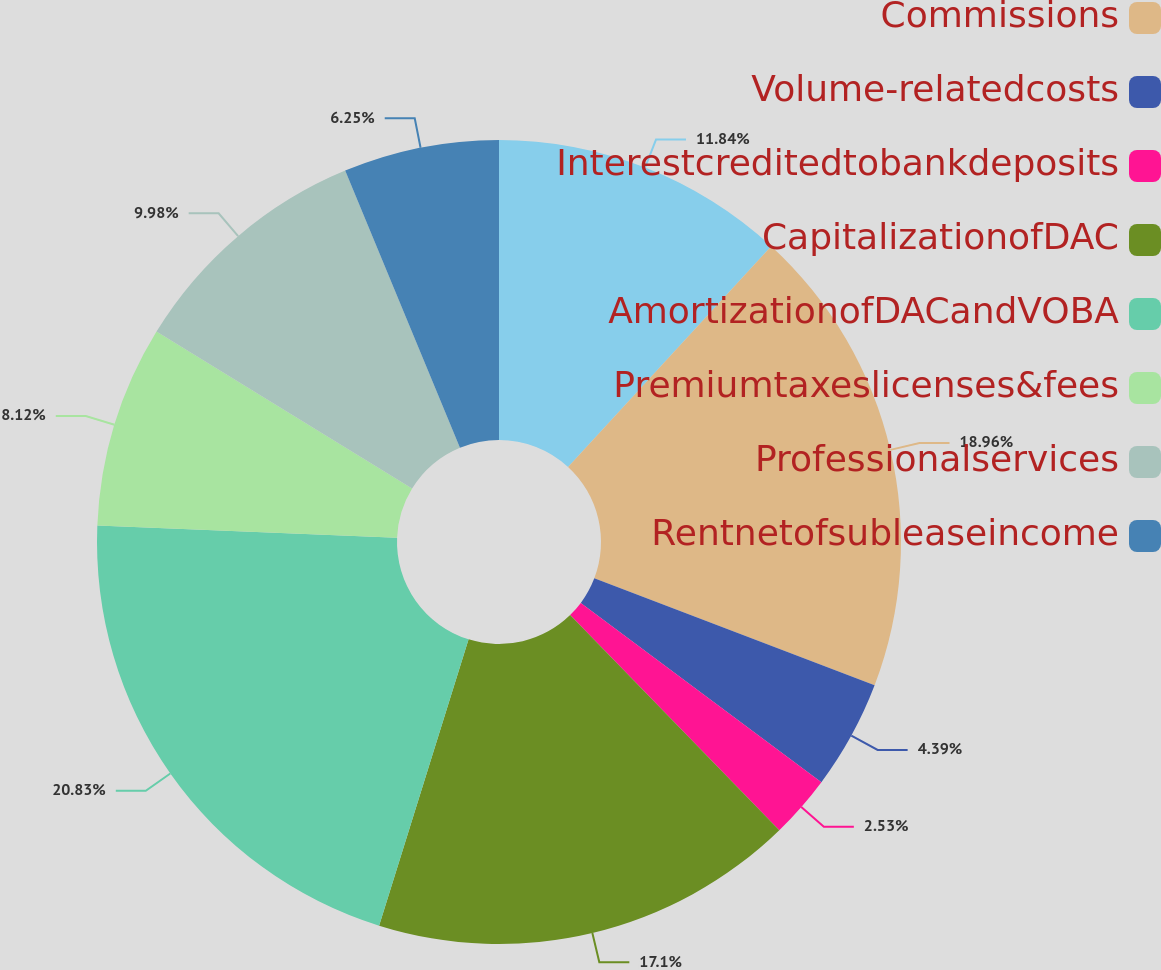Convert chart. <chart><loc_0><loc_0><loc_500><loc_500><pie_chart><ecel><fcel>Commissions<fcel>Volume-relatedcosts<fcel>Interestcreditedtobankdeposits<fcel>CapitalizationofDAC<fcel>AmortizationofDACandVOBA<fcel>Premiumtaxeslicenses&fees<fcel>Professionalservices<fcel>Rentnetofsubleaseincome<nl><fcel>11.84%<fcel>18.96%<fcel>4.39%<fcel>2.53%<fcel>17.1%<fcel>20.83%<fcel>8.12%<fcel>9.98%<fcel>6.25%<nl></chart> 